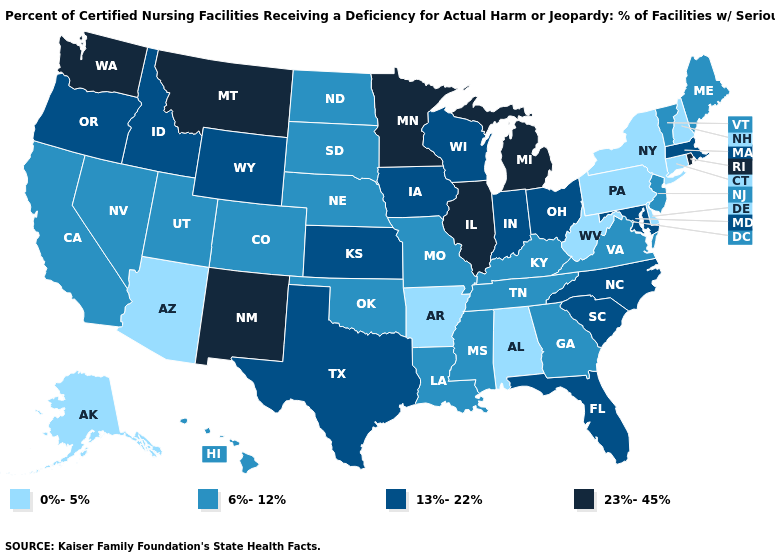Name the states that have a value in the range 6%-12%?
Short answer required. California, Colorado, Georgia, Hawaii, Kentucky, Louisiana, Maine, Mississippi, Missouri, Nebraska, Nevada, New Jersey, North Dakota, Oklahoma, South Dakota, Tennessee, Utah, Vermont, Virginia. Does Alaska have the lowest value in the USA?
Write a very short answer. Yes. Does the map have missing data?
Answer briefly. No. Name the states that have a value in the range 23%-45%?
Short answer required. Illinois, Michigan, Minnesota, Montana, New Mexico, Rhode Island, Washington. Is the legend a continuous bar?
Short answer required. No. What is the value of Connecticut?
Answer briefly. 0%-5%. Does Wyoming have a higher value than New York?
Give a very brief answer. Yes. Name the states that have a value in the range 0%-5%?
Quick response, please. Alabama, Alaska, Arizona, Arkansas, Connecticut, Delaware, New Hampshire, New York, Pennsylvania, West Virginia. Does Hawaii have the same value as New Mexico?
Answer briefly. No. How many symbols are there in the legend?
Write a very short answer. 4. Does Pennsylvania have the highest value in the USA?
Be succinct. No. What is the value of New Mexico?
Keep it brief. 23%-45%. Name the states that have a value in the range 0%-5%?
Quick response, please. Alabama, Alaska, Arizona, Arkansas, Connecticut, Delaware, New Hampshire, New York, Pennsylvania, West Virginia. What is the highest value in the USA?
Short answer required. 23%-45%. What is the highest value in the USA?
Short answer required. 23%-45%. 